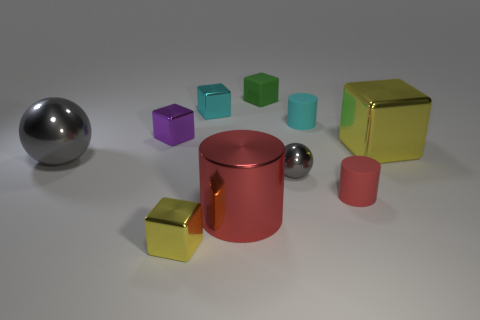Subtract all green cubes. How many cubes are left? 4 Subtract all tiny cyan metal cubes. How many cubes are left? 4 Subtract all brown blocks. Subtract all red spheres. How many blocks are left? 5 Subtract all cylinders. How many objects are left? 7 Subtract 0 blue blocks. How many objects are left? 10 Subtract all tiny shiny blocks. Subtract all metallic cylinders. How many objects are left? 6 Add 2 blocks. How many blocks are left? 7 Add 7 tiny metal spheres. How many tiny metal spheres exist? 8 